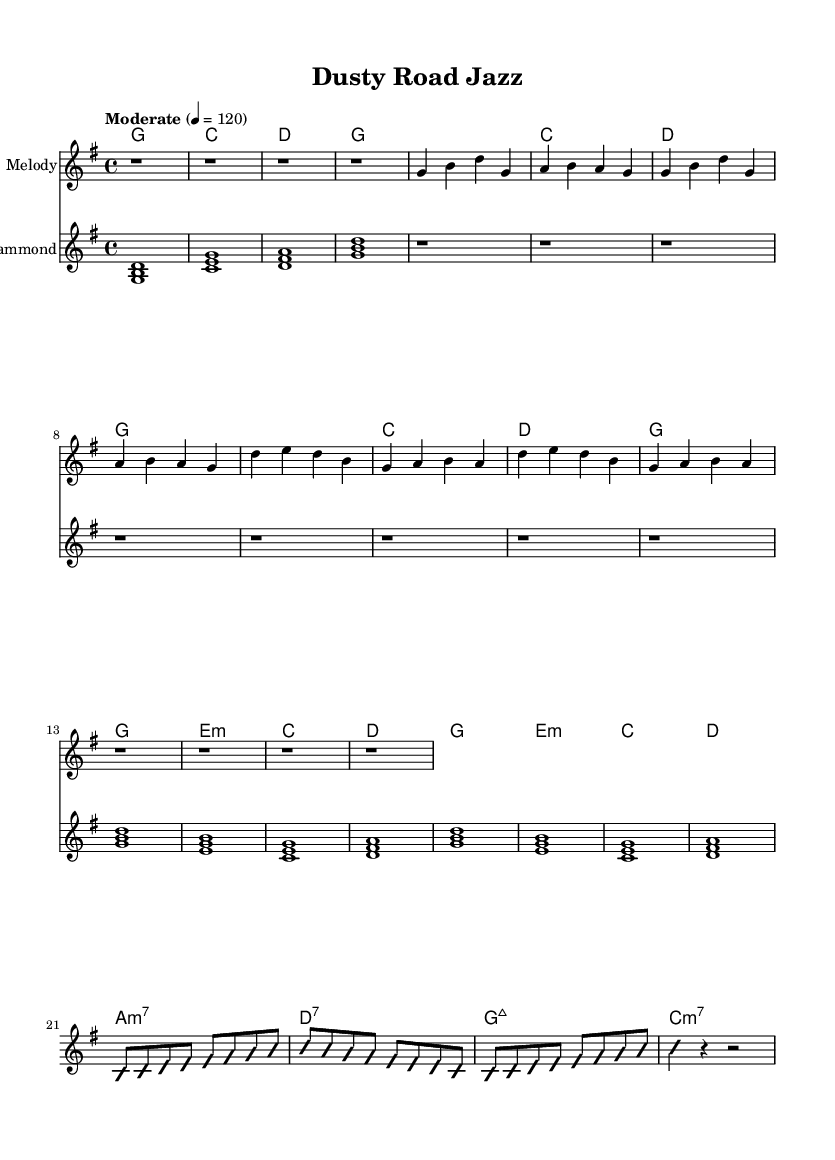What is the key signature of this music? The key signature is G major, which has one sharp (F#). It can be determined by looking at the beginning of the sheet music where the key signature is indicated.
Answer: G major What is the time signature of this music? The time signature is 4/4, indicated right after the key signature at the start of the score. This means there are four beats in each measure and the quarter note gets one beat.
Answer: 4/4 What is the tempo marking of the piece? The tempo is marked as "Moderate" with a metronome marking of 120 beats per minute, which indicates a moderate pace for the music. This is typically found at the beginning of the score.
Answer: Moderate 4 = 120 What chord follows the first verse? After the first verse, the first chord in the chorus is E minor, as seen in the chord progression. Following the verse, there is a section indicating the chords that are played in the chorus.
Answer: E minor In which section do we find a jazz-inspired improvisation? The jazz-inspired improvisation is found in the bridge section, specifically noted under the Hammond organ part, where it states \improvisationOn mentioning improvisation is present. This section features a rhythmic and melodic freedom typical of jazz music.
Answer: Bridge How many measures does the intro consist of? The intro consists of four measures, as indicated by the repeated chord symbols and rests in the melody and Hammond organ parts, each lasting for one measure.
Answer: Four measures What kind of keyboard sound is used in this arrangement? The keyboard sound used in this arrangement is a drawbar organ, which is characteristic of the Hammond organ sound. This can be confirmed in the instrumentation section of the score for the Hammond part.
Answer: Drawbar organ 